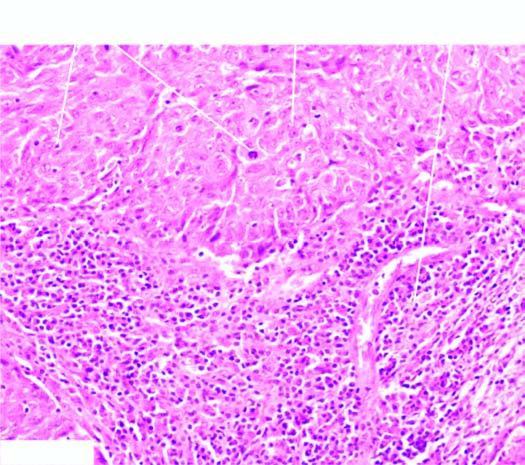re two characteristic features-large tumour cells forming syncytial arrangement and stroma infiltrated richly with lymphocytes?
Answer the question using a single word or phrase. Yes 